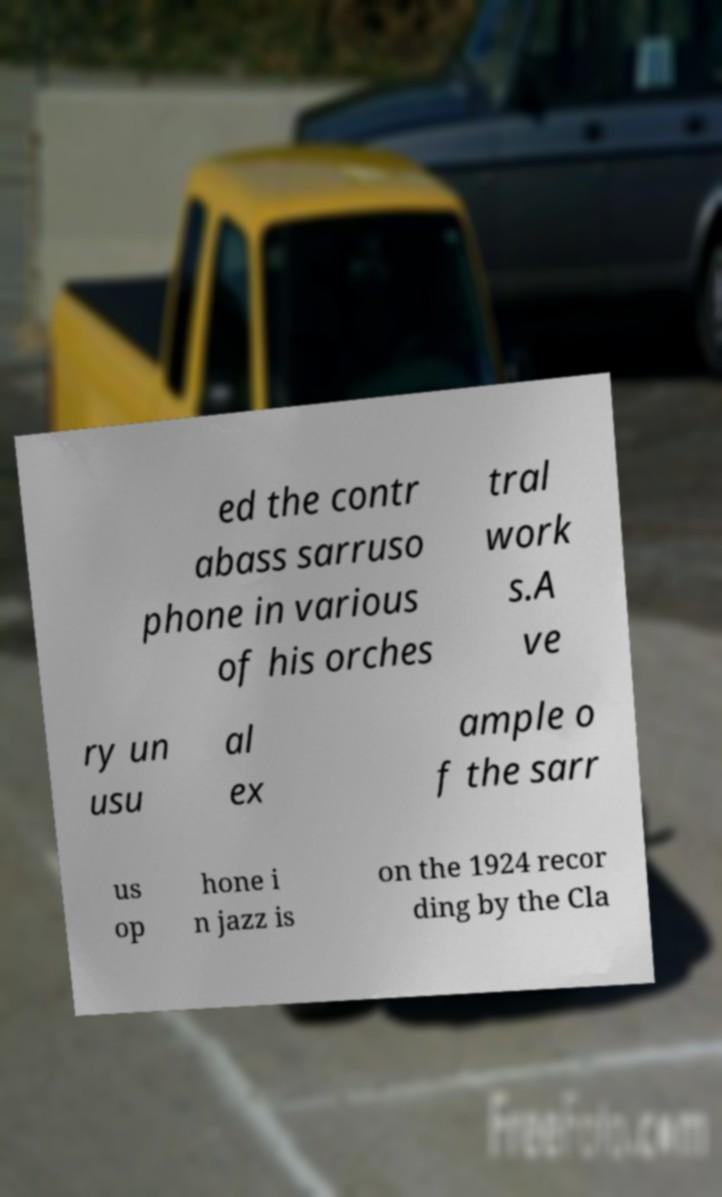Could you assist in decoding the text presented in this image and type it out clearly? ed the contr abass sarruso phone in various of his orches tral work s.A ve ry un usu al ex ample o f the sarr us op hone i n jazz is on the 1924 recor ding by the Cla 